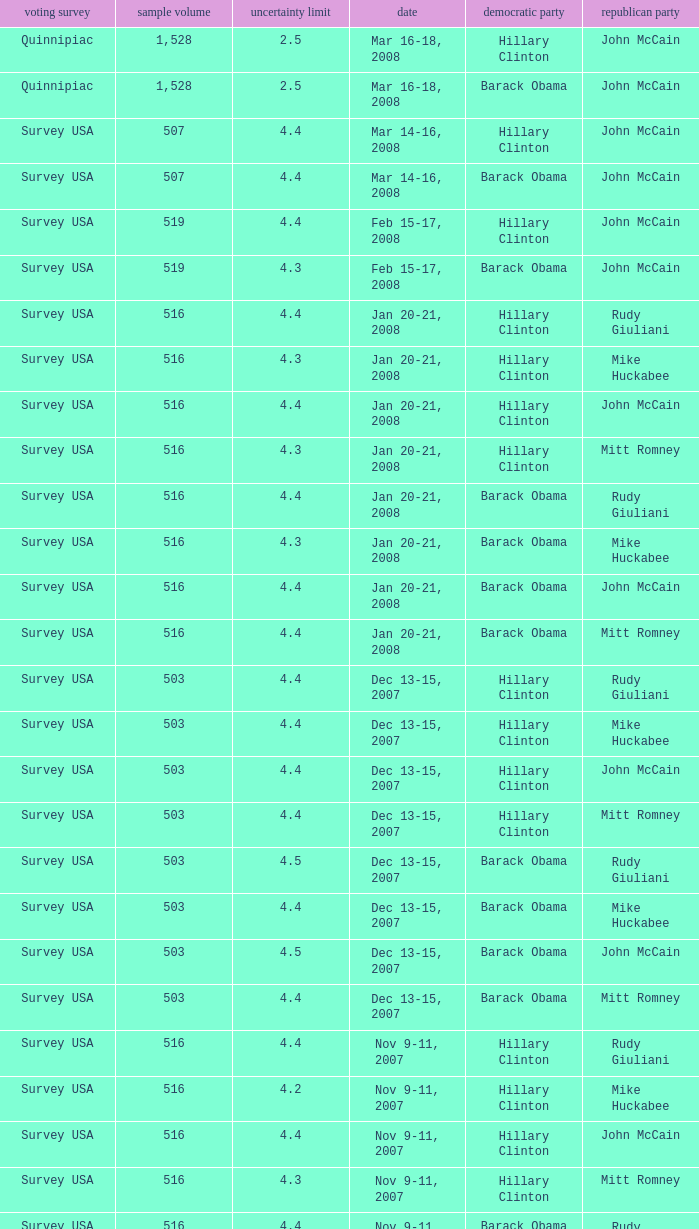What is the sample size of the poll taken on Dec 13-15, 2007 that had a margin of error of more than 4 and resulted with Republican Mike Huckabee? 503.0. 